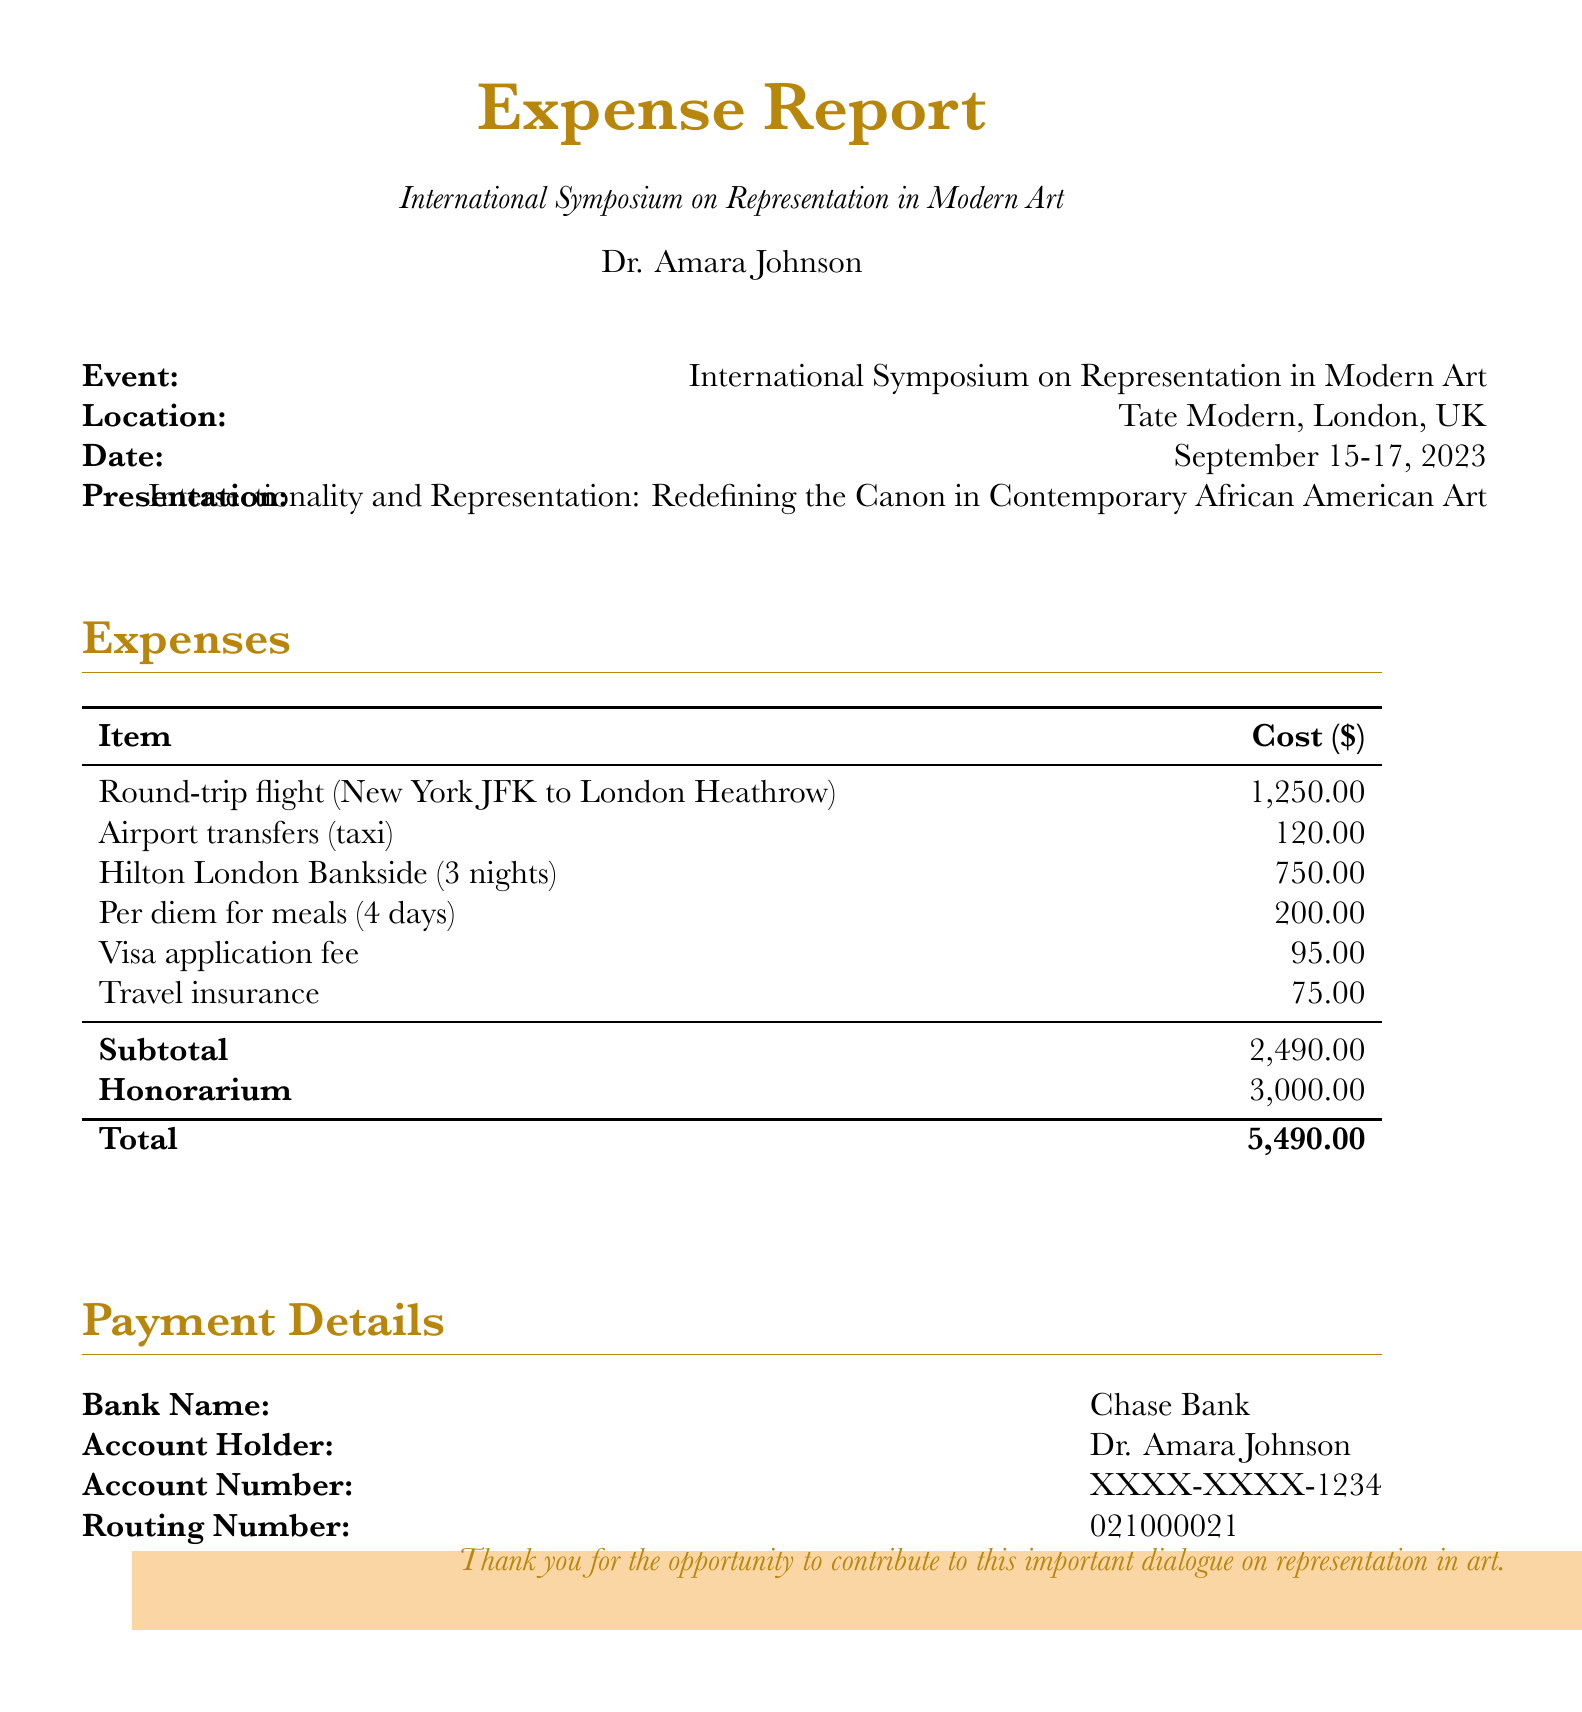What is the event title? The event title is presented at the beginning of the document under the heading "Expense Report."
Answer: International Symposium on Representation in Modern Art Who is the account holder? The account holder's name is provided in the payment details section of the document.
Answer: Dr. Amara Johnson What is the cost of the round-trip flight? The cost of the round-trip flight is listed under the expenses section of the document.
Answer: 1,250.00 What is the total amount requested? The total amount is calculated as the sum of expenses and honorarium at the bottom of the expenses section.
Answer: 5,490.00 How many nights was the accommodation booked for? The number of nights for accommodation can be found under the expenses section, specifically for the hotel stay.
Answer: 3 nights What is the subtotal of expenses? The subtotal is calculated separately in the expenses section before the honorarium is mentioned.
Answer: 2,490.00 What type of fee is included in the expenses? The type of fee is explicitly listed within the expenses section of the document.
Answer: Visa application fee What is the per diem amount for meals? The per diem amount for meals is specified in the expenses breakdown of the document.
Answer: 200.00 Where was the event held? The location of the event is provided in the event details section of the document.
Answer: Tate Modern, London, UK 